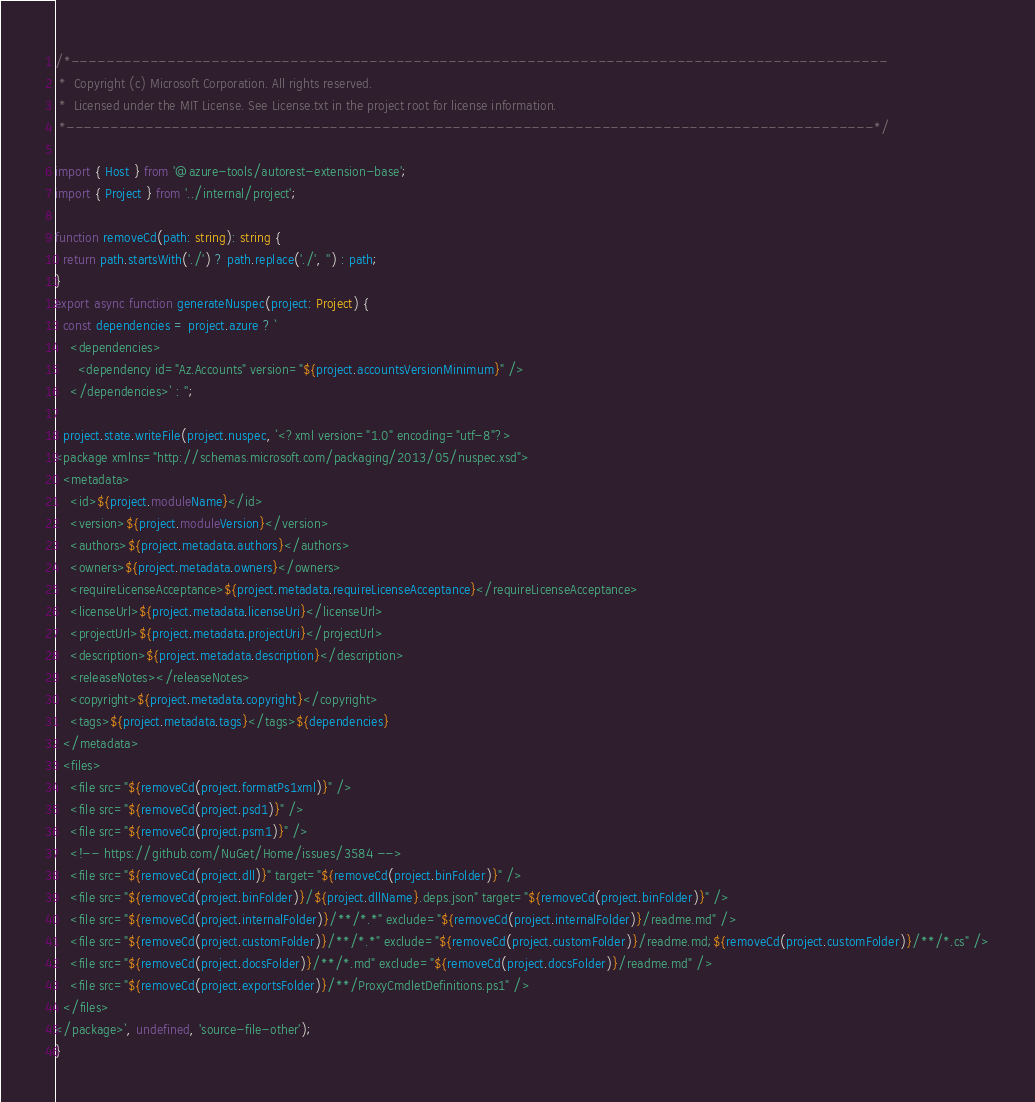Convert code to text. <code><loc_0><loc_0><loc_500><loc_500><_TypeScript_>/*---------------------------------------------------------------------------------------------
 *  Copyright (c) Microsoft Corporation. All rights reserved.
 *  Licensed under the MIT License. See License.txt in the project root for license information.
 *--------------------------------------------------------------------------------------------*/

import { Host } from '@azure-tools/autorest-extension-base';
import { Project } from '../internal/project';

function removeCd(path: string): string {
  return path.startsWith('./') ? path.replace('./', '') : path;
}
export async function generateNuspec(project: Project) {
  const dependencies = project.azure ? `
    <dependencies>
      <dependency id="Az.Accounts" version="${project.accountsVersionMinimum}" />
    </dependencies>` : '';

  project.state.writeFile(project.nuspec, `<?xml version="1.0" encoding="utf-8"?>
<package xmlns="http://schemas.microsoft.com/packaging/2013/05/nuspec.xsd">
  <metadata>
    <id>${project.moduleName}</id>
    <version>${project.moduleVersion}</version>
    <authors>${project.metadata.authors}</authors>
    <owners>${project.metadata.owners}</owners>
    <requireLicenseAcceptance>${project.metadata.requireLicenseAcceptance}</requireLicenseAcceptance>
    <licenseUrl>${project.metadata.licenseUri}</licenseUrl>
    <projectUrl>${project.metadata.projectUri}</projectUrl>
    <description>${project.metadata.description}</description>
    <releaseNotes></releaseNotes>
    <copyright>${project.metadata.copyright}</copyright>
    <tags>${project.metadata.tags}</tags>${dependencies}
  </metadata>
  <files>
    <file src="${removeCd(project.formatPs1xml)}" />
    <file src="${removeCd(project.psd1)}" />
    <file src="${removeCd(project.psm1)}" />
    <!-- https://github.com/NuGet/Home/issues/3584 -->
    <file src="${removeCd(project.dll)}" target="${removeCd(project.binFolder)}" />
    <file src="${removeCd(project.binFolder)}/${project.dllName}.deps.json" target="${removeCd(project.binFolder)}" />
    <file src="${removeCd(project.internalFolder)}/**/*.*" exclude="${removeCd(project.internalFolder)}/readme.md" />
    <file src="${removeCd(project.customFolder)}/**/*.*" exclude="${removeCd(project.customFolder)}/readme.md;${removeCd(project.customFolder)}/**/*.cs" />
    <file src="${removeCd(project.docsFolder)}/**/*.md" exclude="${removeCd(project.docsFolder)}/readme.md" />
    <file src="${removeCd(project.exportsFolder)}/**/ProxyCmdletDefinitions.ps1" />
  </files>
</package>`, undefined, 'source-file-other');
}

</code> 